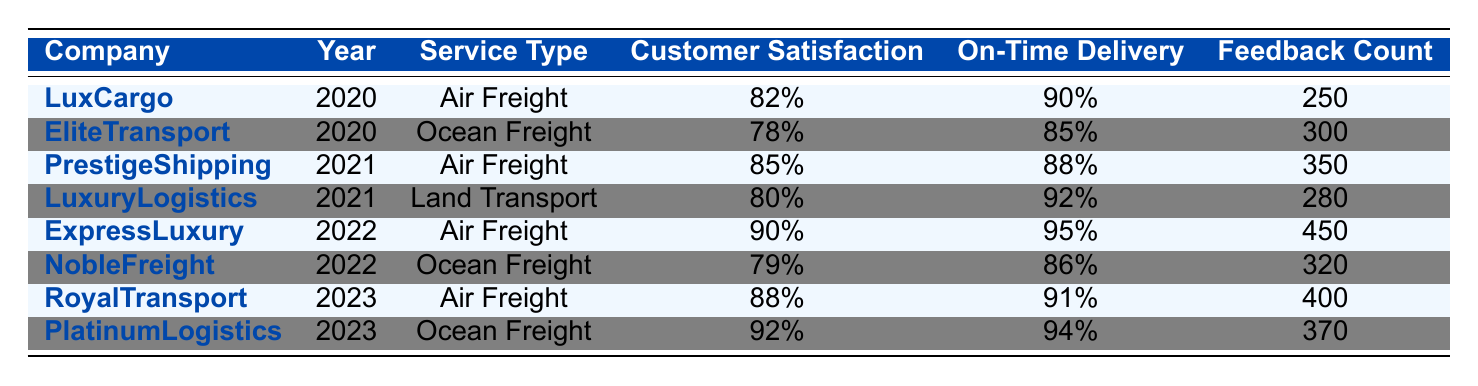What is the highest customer satisfaction rating recorded in 2022? In the year 2022, the customer satisfaction ratings are 90% for ExpressLuxury and 79% for NobleFreight. The highest among these ratings is 90% for ExpressLuxury.
Answer: 90% Which company recorded the lowest delivery on-time percentage in 2020? In 2020, LuxCargo had a delivery on-time percentage of 90% and EliteTransport had 85%. Thus, EliteTransport recorded the lowest delivery on-time percentage.
Answer: EliteTransport What was the average customer satisfaction rating for air freight services across the years? The customer satisfaction ratings for air freight in the years are 82% (2020, LuxCargo), 85% (2021, PrestigeShipping), 90% (2022, ExpressLuxury), and 88% (2023, RoyalTransport). The sum of these ratings is (82 + 85 + 90 + 88) = 345. Dividing by 4 gives an average rating of 345/4 = 86.25%.
Answer: 86.25% In which year did NobleFreight receive the highest number of customer feedback? NobleFreight has a feedback count of 320 in 2022. It does not appear in 2020 and 2021, and the table does not show it being in 2023. Thus, the highest feedback count for NobleFreight is in 2022.
Answer: 2022 Is it true that the customer satisfaction rating for PlatinumLogistics is higher than the average rating of all companies in 2023? In 2023, PlatinumLogistics has a customer satisfaction rating of 92%. The average rating for all companies in 2023 is calculated as (88 + 92) / 2 = 90%. Since 92% is greater than 90%, the statement is true.
Answer: Yes What is the change in customer satisfaction rating for EliteTransport from 2020 to 2021? In 2020, EliteTransport had a customer satisfaction rating of 78%. Since it does not appear in 2021, the change is from 78% to 0%, indicating a decrease of 78%.
Answer: 78% decrease How many total customer feedback counts were recorded for all companies in 2022? The customer feedback counts for 2022 are 450 (ExpressLuxury) and 320 (NobleFreight). Adding these counts together gives a total of 450 + 320 = 770.
Answer: 770 Which service type had the highest on-time delivery percentage in 2023? In 2023, RoyalTransport had an on-time delivery percentage of 91% in air freight, and PlatinumLogistics had 94% in ocean freight. Thus, ocean freight had the highest on-time delivery percentage.
Answer: Ocean Freight 